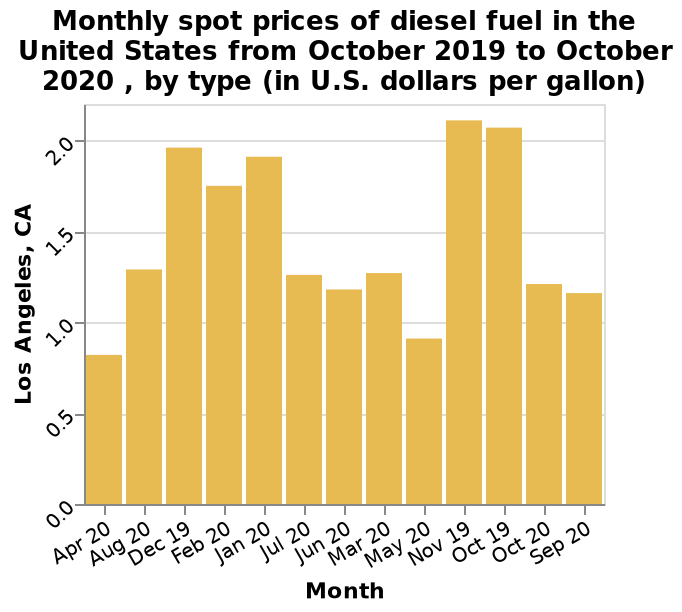<image>
Are fuel prices affected by seasonal changes? Yes, fuel prices are affected by seasonal changes, with the highest prices occurring in the winter. 